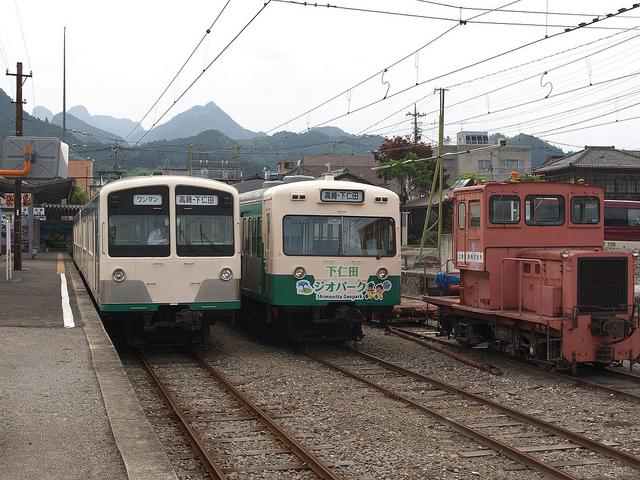How many trains are in the image?
Answer briefly. 2. Are there mountains in the background?
Be succinct. Yes. What do these vehicles transport?
Quick response, please. People. 